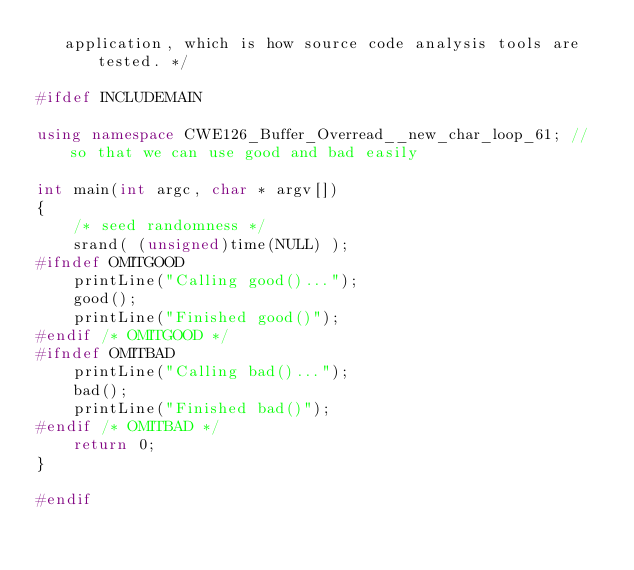Convert code to text. <code><loc_0><loc_0><loc_500><loc_500><_C++_>   application, which is how source code analysis tools are tested. */

#ifdef INCLUDEMAIN

using namespace CWE126_Buffer_Overread__new_char_loop_61; // so that we can use good and bad easily

int main(int argc, char * argv[])
{
    /* seed randomness */
    srand( (unsigned)time(NULL) );
#ifndef OMITGOOD
    printLine("Calling good()...");
    good();
    printLine("Finished good()");
#endif /* OMITGOOD */
#ifndef OMITBAD
    printLine("Calling bad()...");
    bad();
    printLine("Finished bad()");
#endif /* OMITBAD */
    return 0;
}

#endif
</code> 